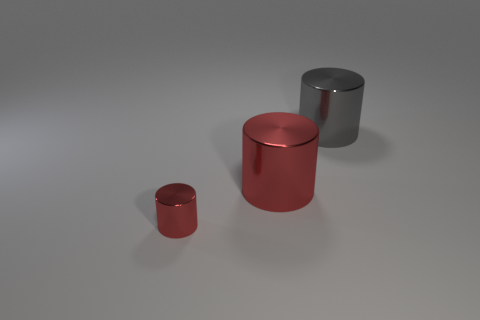Subtract all big gray shiny cylinders. How many cylinders are left? 2 Subtract 3 cylinders. How many cylinders are left? 0 Add 3 gray cylinders. How many objects exist? 6 Subtract all gray cylinders. How many cylinders are left? 2 Subtract all yellow cubes. How many red cylinders are left? 2 Subtract all green cylinders. Subtract all gray balls. How many cylinders are left? 3 Subtract 0 gray blocks. How many objects are left? 3 Subtract all tiny red spheres. Subtract all large red metallic things. How many objects are left? 2 Add 2 big cylinders. How many big cylinders are left? 4 Add 1 big things. How many big things exist? 3 